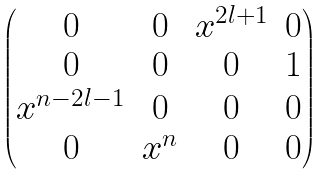Convert formula to latex. <formula><loc_0><loc_0><loc_500><loc_500>\begin{pmatrix} 0 & 0 & x ^ { 2 l + 1 } & 0 \\ 0 & 0 & 0 & 1 \\ x ^ { n - 2 l - 1 } & 0 & 0 & 0 \\ 0 & x ^ { n } & 0 & 0 \end{pmatrix}</formula> 